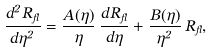<formula> <loc_0><loc_0><loc_500><loc_500>\frac { d ^ { 2 } R _ { \Lambda } } { d \eta ^ { 2 } } = \frac { A ( \eta ) } { \eta } \, \frac { d R _ { \Lambda } } { d \eta } + \frac { B ( \eta ) } { \eta ^ { 2 } } \, R _ { \Lambda } ,</formula> 